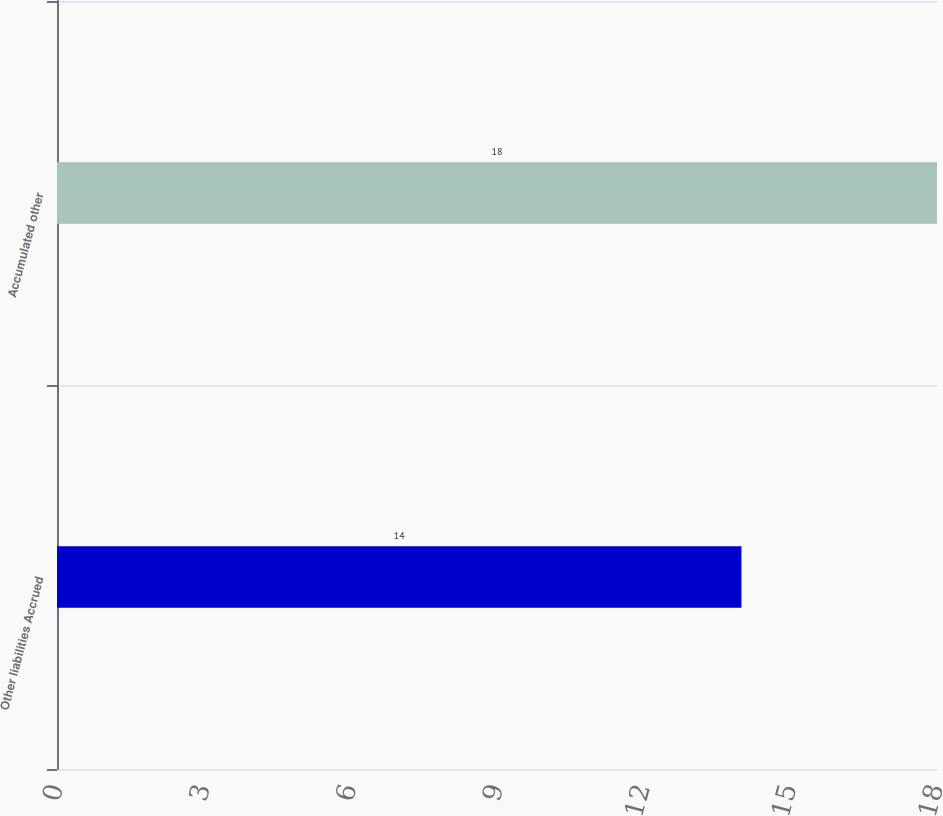<chart> <loc_0><loc_0><loc_500><loc_500><bar_chart><fcel>Other liabilities Accrued<fcel>Accumulated other<nl><fcel>14<fcel>18<nl></chart> 